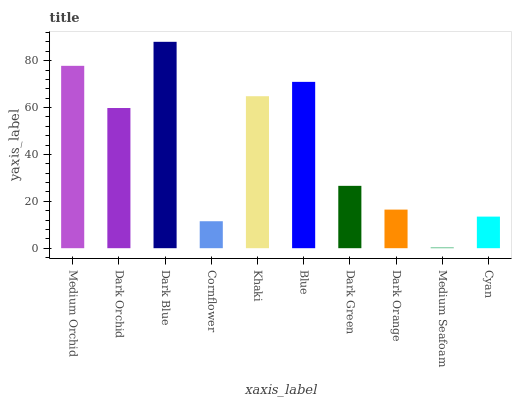Is Medium Seafoam the minimum?
Answer yes or no. Yes. Is Dark Blue the maximum?
Answer yes or no. Yes. Is Dark Orchid the minimum?
Answer yes or no. No. Is Dark Orchid the maximum?
Answer yes or no. No. Is Medium Orchid greater than Dark Orchid?
Answer yes or no. Yes. Is Dark Orchid less than Medium Orchid?
Answer yes or no. Yes. Is Dark Orchid greater than Medium Orchid?
Answer yes or no. No. Is Medium Orchid less than Dark Orchid?
Answer yes or no. No. Is Dark Orchid the high median?
Answer yes or no. Yes. Is Dark Green the low median?
Answer yes or no. Yes. Is Dark Orange the high median?
Answer yes or no. No. Is Khaki the low median?
Answer yes or no. No. 